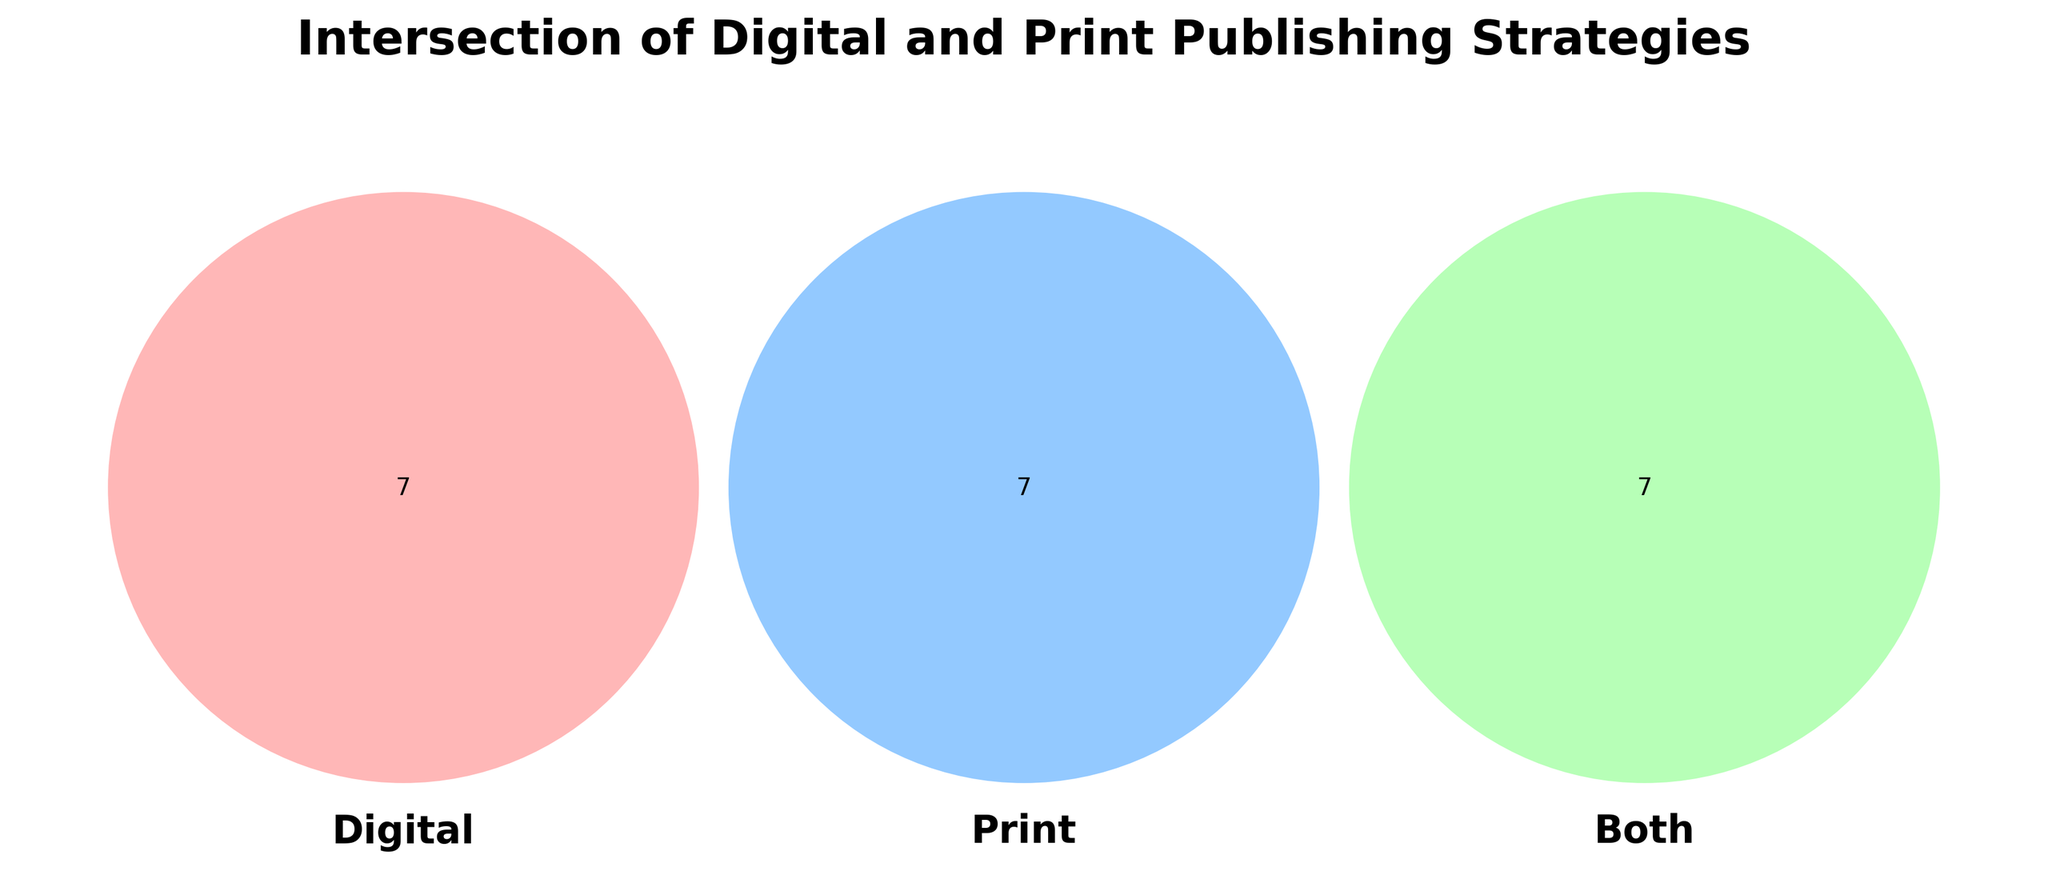what is the title of the figure? The title is located at the top of the figure and reads: "Intersection of Digital and Print Publishing Strategies."
Answer: Intersection of Digital and Print Publishing Strategies How many categories are unique to digital publishing? To find the number of categories unique to digital, look at the leftmost circle with no overlap, and count the entries: "E-books," "Online marketing," "Social media engagement," "Digital rights management," "Subscription services," "Web analytics," and "Influencer collaborations."
Answer: 7 What are the strategies shared between digital and print publishing? The shared strategies are in the overlapping section of the circles labeled "Both." The entries are: "Hybrid publishing," "Multichannel distribution," "Author branding," "Metadata optimization," "Print-on-demand," "Content repurposing," and "Audiobook production."
Answer: 7 Which category has more unique strategies: digital or print publishing? Count the unique strategies in both digital and print. Digital has 7 strategies, while print has 6 ("Hardcovers," "Book fairs," "Bookstore signings," "ISBN assignment," "Limited editions," and "Direct mail"). Digital has more unique strategies.
Answer: Digital How many total unique strategies are there for digital, print, and both combined? Add the number of strategies unique to digital (7), print (6), and shared (7). The total is 7 + 6 + 7.
Answer: 20 Is "Book reviews" a strategy included in digital, print, or both? Locate "Book reviews" within the circles on the Venn Diagram. It is found in the "Print" circle.
Answer: Print Which strategies involve distribution channels? Look for keywords related to distribution in the diagram: "Multichannel distribution," and "Print-on-demand" are in both, while "Book fairs" is in print.
Answer: Multichannel distribution, Print-on-demand, Book fairs Compare the number of digital and print-only strategies related to author engagement. Digital has "Social media engagement" while print has "Bookstore signings" (1 each). Compute the number.
Answer: equal: 1 each What digital strategy is counterpart to "ISBN assignment" in print? Find where "ISBN assignment" appears in the print section, then check digital and overlap sections for a comparable strategy. "Digital rights management" in digital serves a similar regulatory/identification purpose.
Answer: Digital rights management 